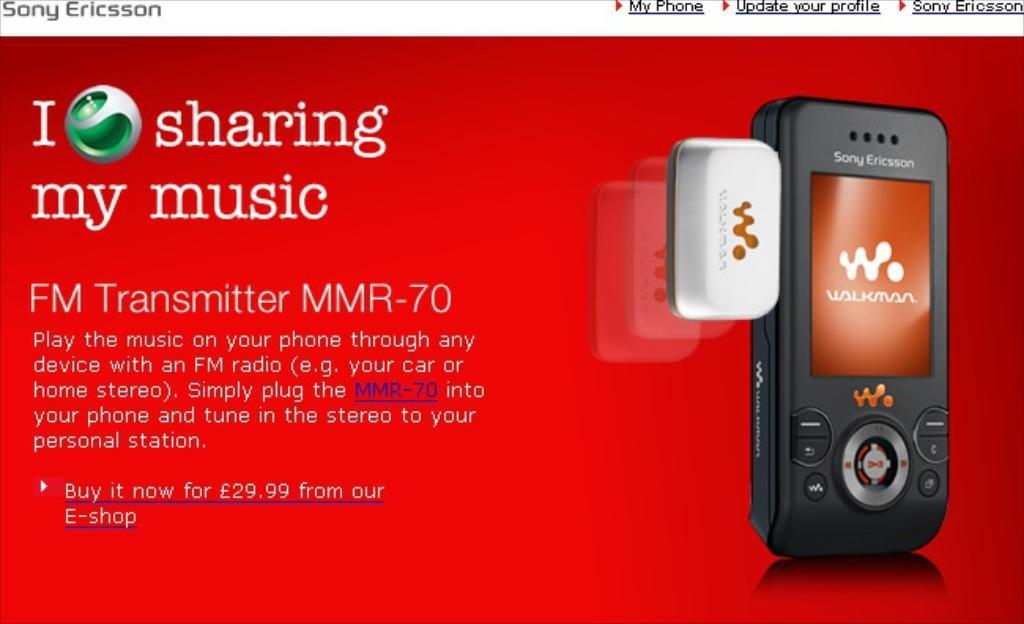<image>
Present a compact description of the photo's key features. A red ad for a Sony Ericsson Walkman. 